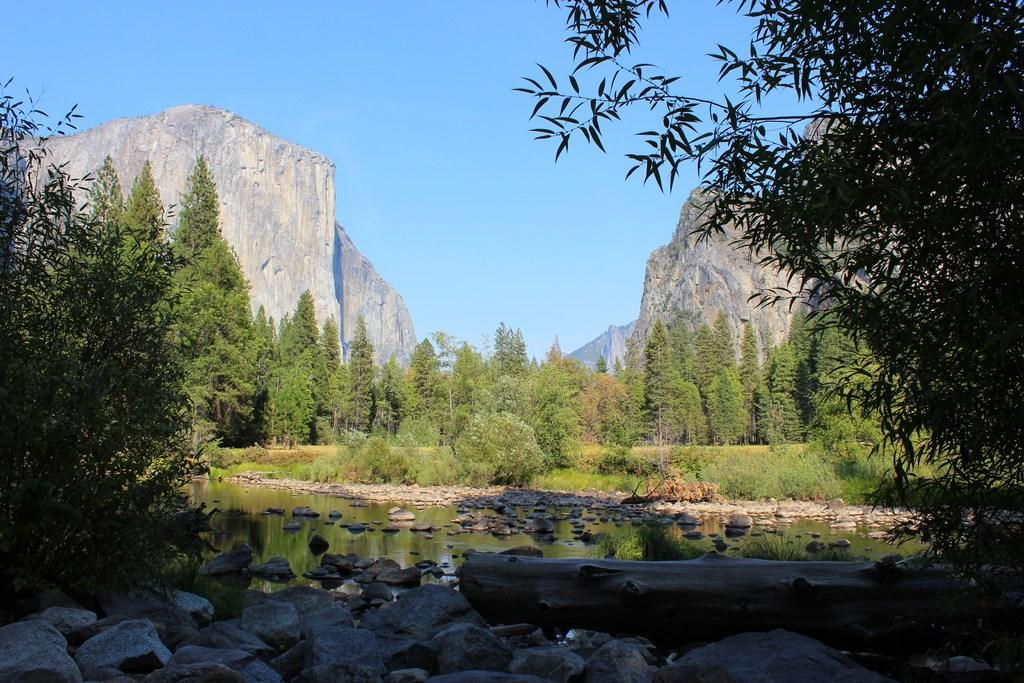What type of vegetation can be seen in the image? There are many trees and plants in the image. What other natural elements are present in the image? There are rocks and a wooden log visible in the image. Is there any water visible in the image? Yes, there is water visible in the image. What can be seen in the background of the image? The background of the image includes rock hills and the sky. What type of yam is being used as a twig in the image? There is no yam or twig present in the image. What type of loaf is visible in the image? There is no loaf present in the image. 